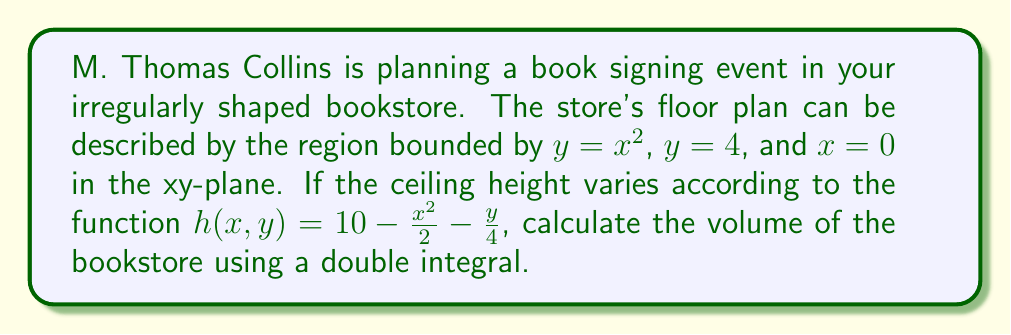Teach me how to tackle this problem. To find the volume of the irregularly shaped bookstore, we need to set up and evaluate a double integral. The steps are as follows:

1) Identify the region of integration:
   The region is bounded by $y = x^2$, $y = 4$, and $x = 0$.

2) Set up the double integral:
   $$V = \int\int_R h(x,y) \, dA$$
   where $h(x,y) = 10 - \frac{x^2}{2} - \frac{y}{4}$ is the ceiling height function.

3) Choose the order of integration:
   We'll integrate with respect to y first, then x.

4) Set up the limits of integration:
   $x$ goes from 0 to 2 (solve $x^2 = 4$ for the upper limit of x)
   $y$ goes from $x^2$ to 4

5) Write the double integral:
   $$V = \int_0^2 \int_{x^2}^4 \left(10 - \frac{x^2}{2} - \frac{y}{4}\right) \, dy \, dx$$

6) Evaluate the inner integral:
   $$V = \int_0^2 \left[\left(10 - \frac{x^2}{2}\right)y - \frac{y^2}{8}\right]_{x^2}^4 \, dx$$
   $$= \int_0^2 \left[\left(40 - 2x^2 - 2\right) - \left(10x^2 - \frac{x^4}{2} - \frac{x^4}{2}\right)\right] \, dx$$
   $$= \int_0^2 \left(38 - 12x^2 + x^4\right) \, dx$$

7) Evaluate the outer integral:
   $$V = \left[38x - 4x^3 + \frac{x^5}{5}\right]_0^2$$
   $$= \left(76 - 32 + \frac{32}{5}\right) - 0$$
   $$= 76 - 32 + \frac{32}{5} = 44 + \frac{32}{5} = \frac{252}{5}$$

Therefore, the volume of the bookstore is $\frac{252}{5}$ cubic units.
Answer: $\frac{252}{5}$ cubic units 